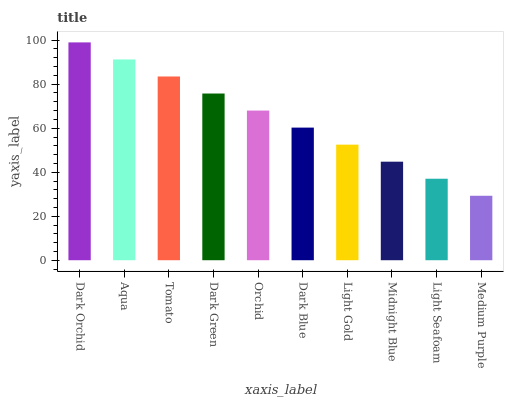Is Medium Purple the minimum?
Answer yes or no. Yes. Is Dark Orchid the maximum?
Answer yes or no. Yes. Is Aqua the minimum?
Answer yes or no. No. Is Aqua the maximum?
Answer yes or no. No. Is Dark Orchid greater than Aqua?
Answer yes or no. Yes. Is Aqua less than Dark Orchid?
Answer yes or no. Yes. Is Aqua greater than Dark Orchid?
Answer yes or no. No. Is Dark Orchid less than Aqua?
Answer yes or no. No. Is Orchid the high median?
Answer yes or no. Yes. Is Dark Blue the low median?
Answer yes or no. Yes. Is Light Seafoam the high median?
Answer yes or no. No. Is Medium Purple the low median?
Answer yes or no. No. 